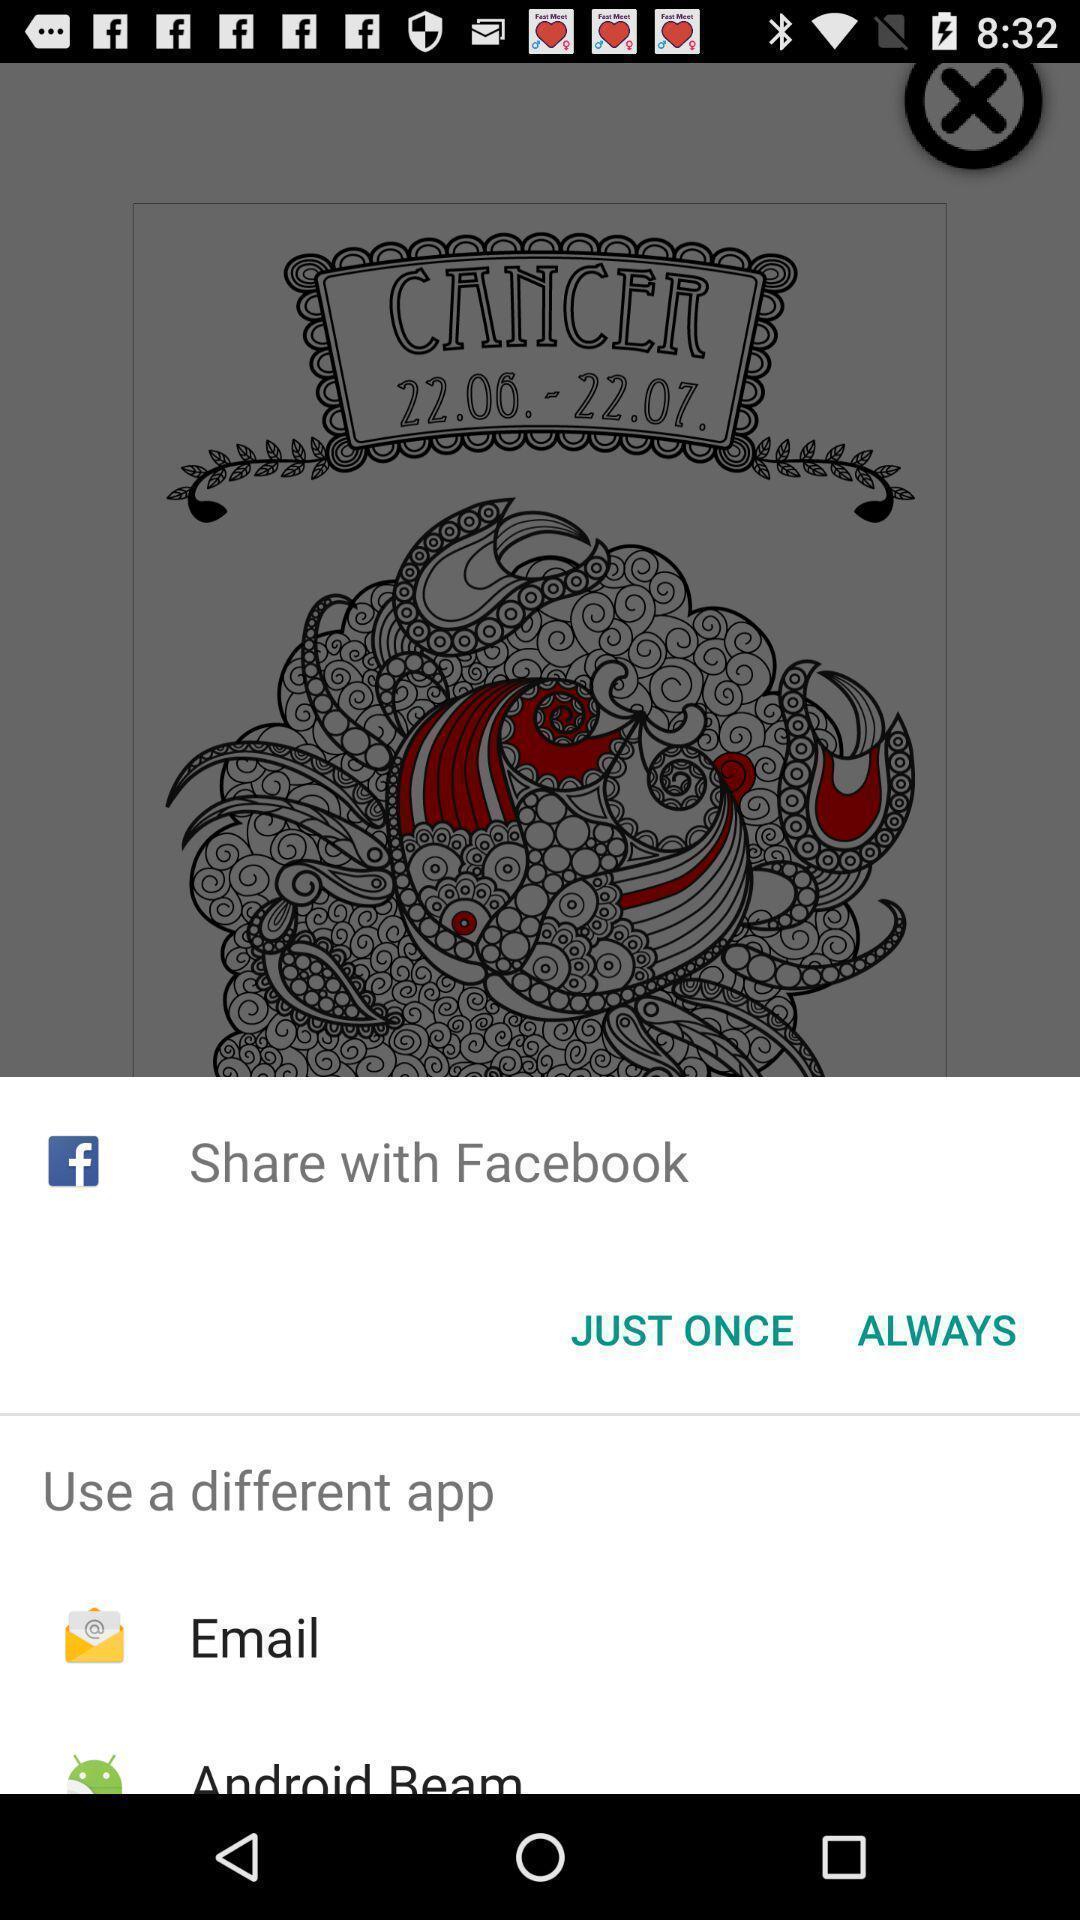What is the overall content of this screenshot? Push up page showing app preference to share. 